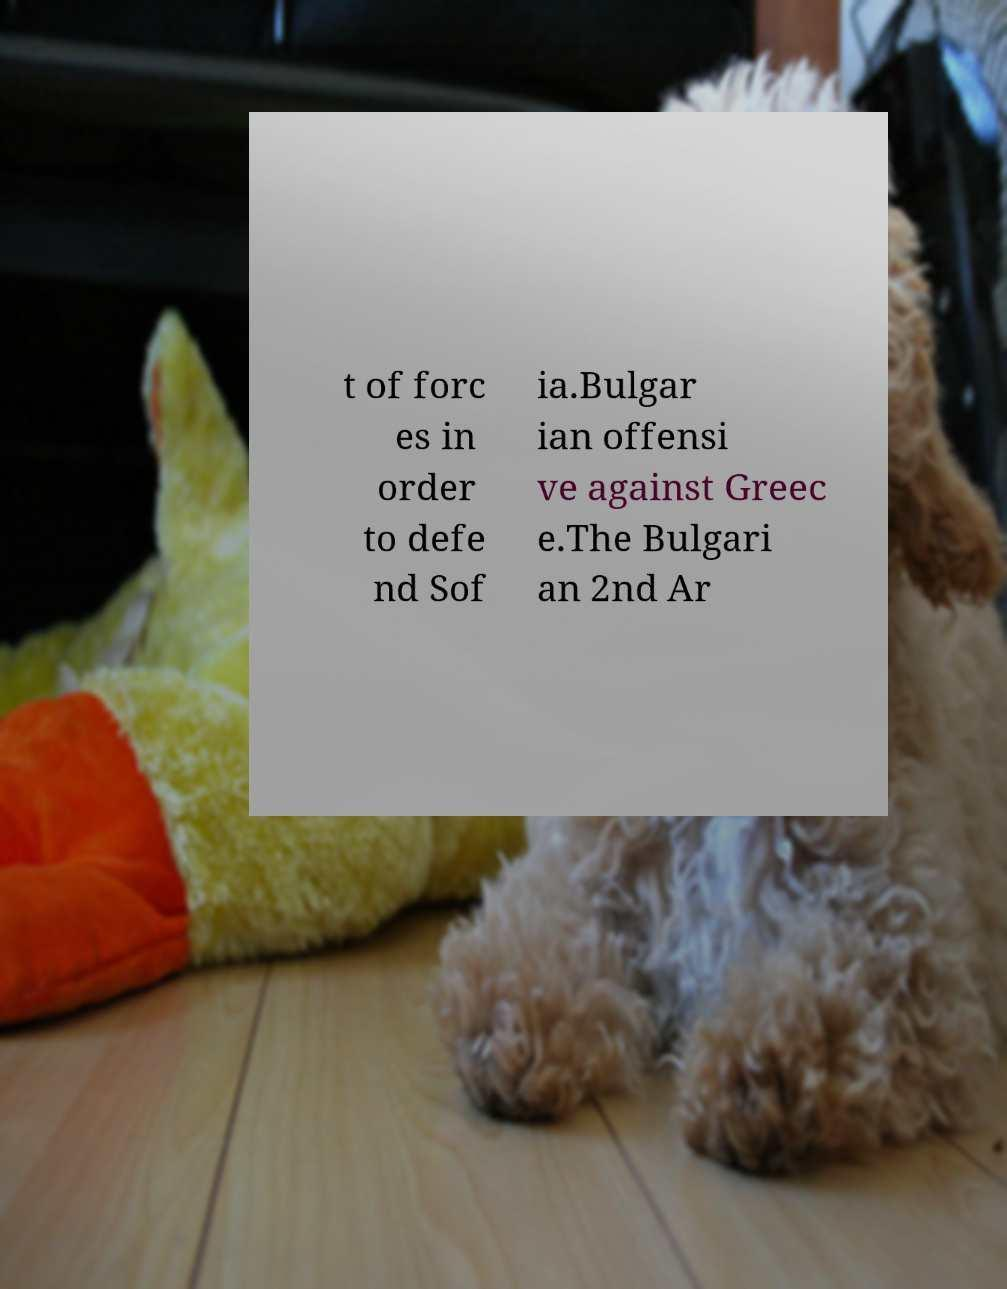Could you assist in decoding the text presented in this image and type it out clearly? t of forc es in order to defe nd Sof ia.Bulgar ian offensi ve against Greec e.The Bulgari an 2nd Ar 